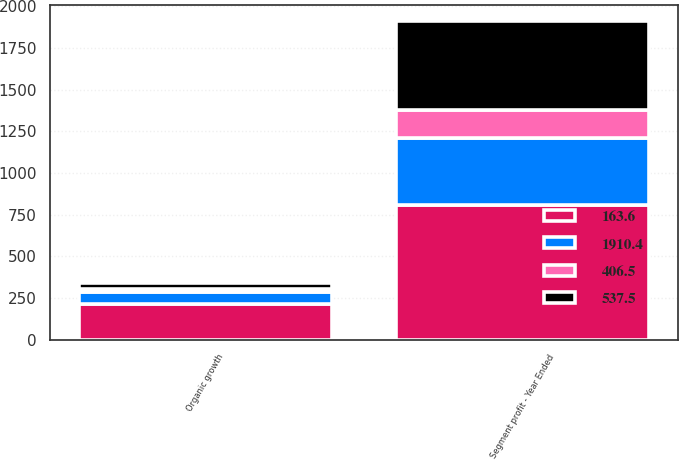<chart> <loc_0><loc_0><loc_500><loc_500><stacked_bar_chart><ecel><fcel>Segment profit - Year Ended<fcel>Organic growth<nl><fcel>537.5<fcel>537.5<fcel>35<nl><fcel>163.6<fcel>805.8<fcel>211.8<nl><fcel>406.5<fcel>163.6<fcel>14.2<nl><fcel>1910.4<fcel>406.5<fcel>76.6<nl></chart> 